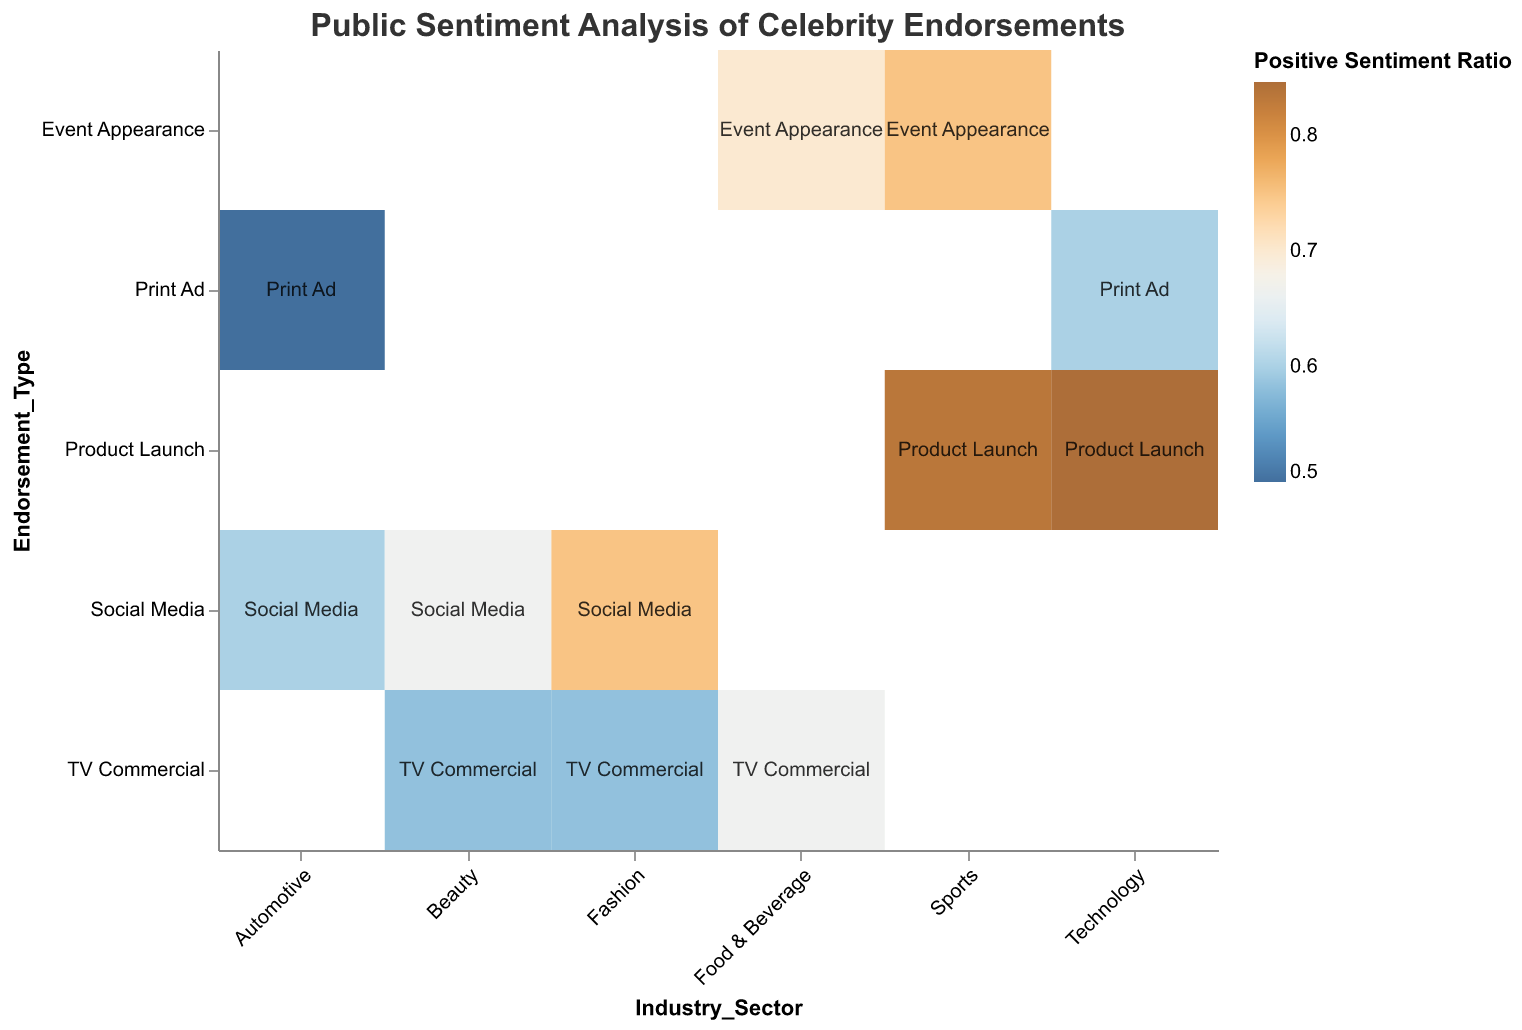Which industry sector has the highest positive sentiment for a product launch endorsement? To find this, look at the cells where the endorsement type is "Product Launch" and compare the positive sentiment ratios. Both "Technology" and "Sports" are shown, and "Sports" has 50 positive sentiment while "Technology" has 55. Therefore, "Technology" has the highest positive sentiment ratio.
Answer: Technology What is the title of the mosaic plot? This can be found at the top of the plot. It summarizes the figure's content.
Answer: Public Sentiment Analysis of Celebrity Endorsements Which endorsement type within the Fashion sector garnered more positive sentiment, Social Media or TV Commercial? Look at the Fashion sector and compare the positive sentiment in Social Media (45) and TV Commercial (35).
Answer: Social Media How does the positive sentiment for Social Media endorsements in the Beauty sector compare to that in the Fashion sector? Look at the cells corresponding to Social Media in Beauty (40) and Fashion (45). Beauty has 40 and Fashion has 45, so Fashion has a higher positive sentiment.
Answer: Fashion Which sector and endorsement type have the lowest positive sentiment ratio, and what is that ratio? To find this, compare all the positive sentiment ratios. "Automotive" sector with "Print Ad" endorsement type has the lowest positive sentiment of 25, and the total sentiment is 50, making the ratio 25/50 = 0.5.
Answer: Automotive, Print Ad, 0.5 What is the positive sentiment ratio for the Food & Beverage's TV Commercial endorsements? First, sum the positive and negative sentiments for this endorsement (40+20=60). The positive ratio is 40/60 = 2/3 ≈ 0.67.
Answer: 0.67 Which endorsement type is the most positively perceived in the Technology sector? Look at the positive sentiment for Technology. Compare "Product Launch" (55) and "Print Ad" (30). The "Product Launch" has the highest positive sentiment.
Answer: Product Launch Are there any endorsement types that consistently receive higher positive sentiments across multiple industry sectors? Compare endorsement types across sectors. "Product Launch" in both Technology and Sports has high positive sentiments (55 and 50).
Answer: Product Launch Which industry has the most diverse range of endorsement types analyzed in the plot? Look at the number of different types of endorsements listed per industry. Fashion appears to have both "Social Media" and "TV Commercial" endorsements, along with positive and negative sentiments for each.
Answer: Fashion What are the industry sectors where TV Commercial endorsements have been analyzed, and how do their positive sentiments compare? Identify the sectors where TV Commercials are listed: "Fashion," "Food & Beverage," and "Beauty." Their positive sentiments are 35 for Fashion, 40 for Food & Beverage, and 35 for Beauty. Comparing these, Food & Beverage has the highest positive sentiment.
Answer: Fashion, Food & Beverage, Beauty. Food & Beverage has the highest positive sentiment 